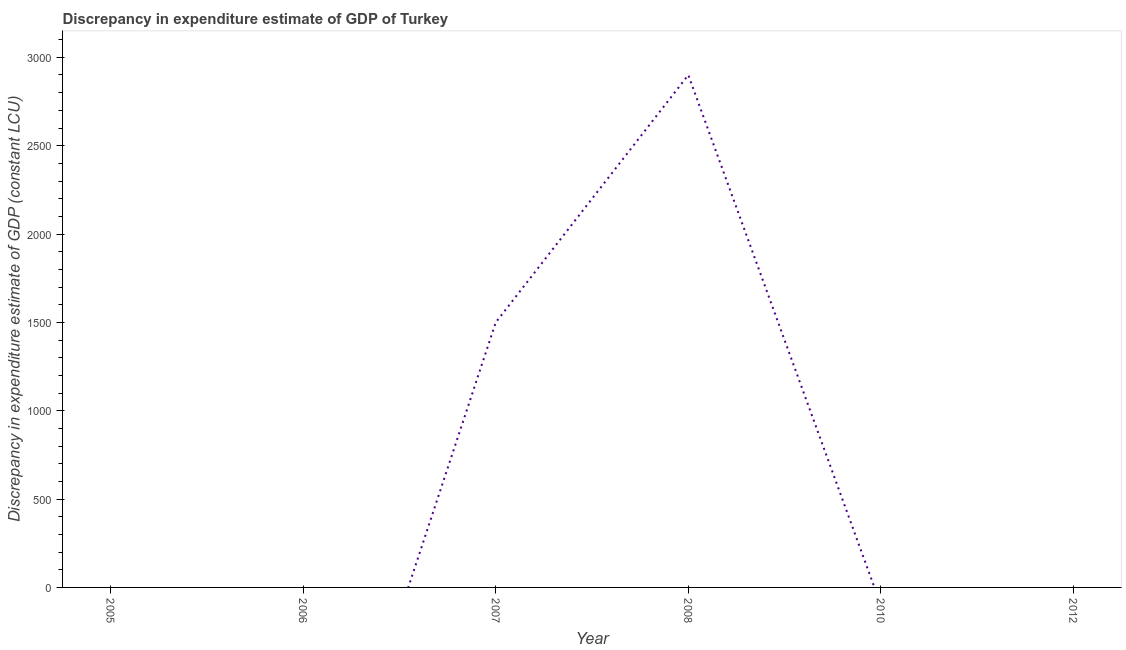Across all years, what is the maximum discrepancy in expenditure estimate of gdp?
Ensure brevity in your answer.  2900. Across all years, what is the minimum discrepancy in expenditure estimate of gdp?
Your answer should be compact. 0. What is the sum of the discrepancy in expenditure estimate of gdp?
Provide a short and direct response. 4400. What is the difference between the discrepancy in expenditure estimate of gdp in 2007 and 2008?
Your answer should be very brief. -1400. What is the average discrepancy in expenditure estimate of gdp per year?
Give a very brief answer. 733.33. What is the difference between the highest and the lowest discrepancy in expenditure estimate of gdp?
Give a very brief answer. 2900. In how many years, is the discrepancy in expenditure estimate of gdp greater than the average discrepancy in expenditure estimate of gdp taken over all years?
Offer a very short reply. 2. Does the discrepancy in expenditure estimate of gdp monotonically increase over the years?
Your response must be concise. No. How many lines are there?
Offer a very short reply. 1. What is the title of the graph?
Give a very brief answer. Discrepancy in expenditure estimate of GDP of Turkey. What is the label or title of the Y-axis?
Your answer should be compact. Discrepancy in expenditure estimate of GDP (constant LCU). What is the Discrepancy in expenditure estimate of GDP (constant LCU) in 2005?
Your response must be concise. 0. What is the Discrepancy in expenditure estimate of GDP (constant LCU) of 2007?
Offer a very short reply. 1500. What is the Discrepancy in expenditure estimate of GDP (constant LCU) of 2008?
Your answer should be very brief. 2900. What is the difference between the Discrepancy in expenditure estimate of GDP (constant LCU) in 2007 and 2008?
Make the answer very short. -1400. What is the ratio of the Discrepancy in expenditure estimate of GDP (constant LCU) in 2007 to that in 2008?
Give a very brief answer. 0.52. 